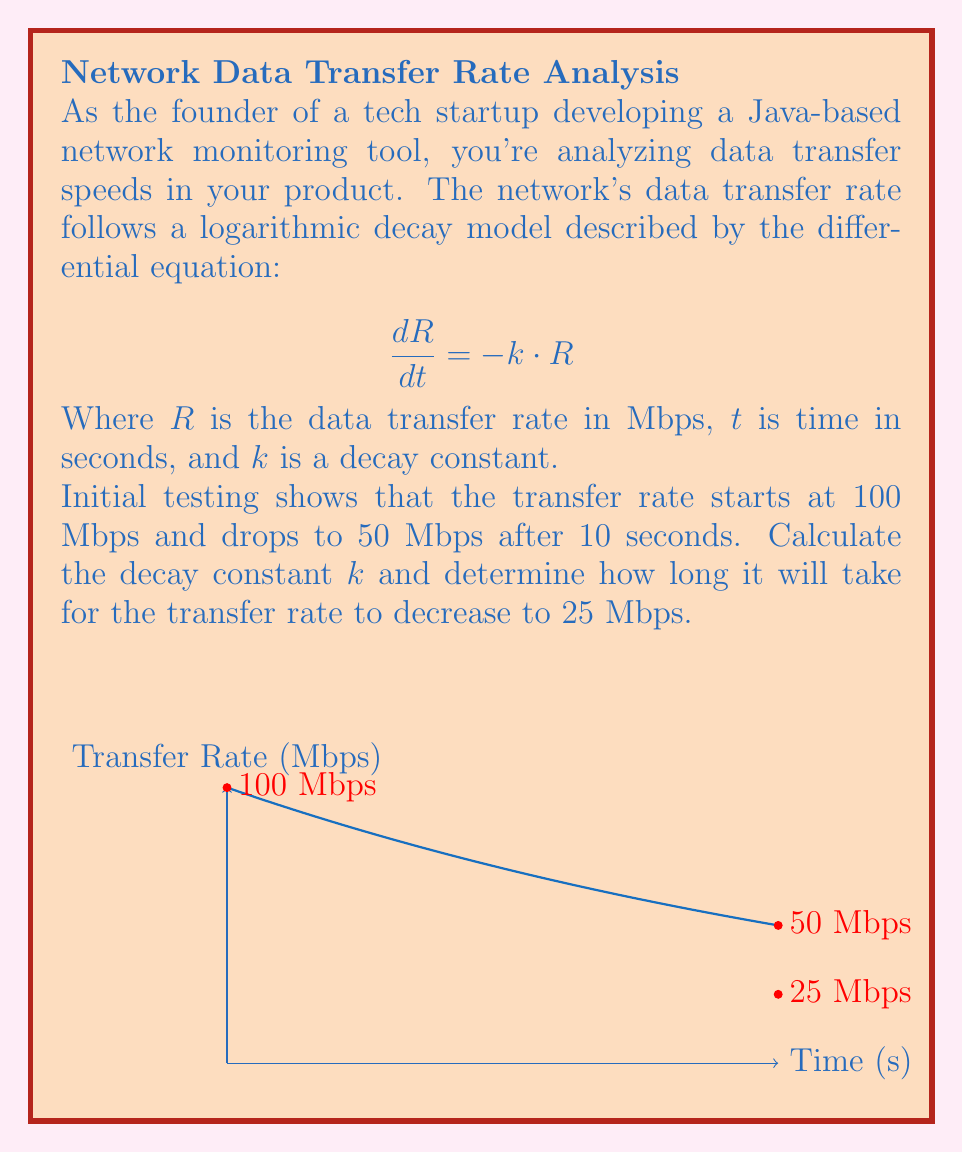Can you solve this math problem? Let's solve this problem step by step:

1) The general solution to the differential equation $\frac{dR}{dt} = -k \cdot R$ is:
   $$R(t) = R_0 \cdot e^{-kt}$$
   where $R_0$ is the initial transfer rate.

2) We know that $R_0 = 100$ Mbps and after 10 seconds, $R(10) = 50$ Mbps. Let's use these to find $k$:
   $$50 = 100 \cdot e^{-10k}$$

3) Dividing both sides by 100:
   $$0.5 = e^{-10k}$$

4) Taking the natural logarithm of both sides:
   $$\ln(0.5) = -10k$$

5) Solving for $k$:
   $$k = -\frac{\ln(0.5)}{10} \approx 0.069315$$

6) Now that we have $k$, let's find the time $t$ when the rate drops to 25 Mbps:
   $$25 = 100 \cdot e^{-0.069315t}$$

7) Dividing both sides by 100:
   $$0.25 = e^{-0.069315t}$$

8) Taking the natural logarithm of both sides:
   $$\ln(0.25) = -0.069315t$$

9) Solving for $t$:
   $$t = -\frac{\ln(0.25)}{0.069315} \approx 20.09$$

Therefore, it will take approximately 20.09 seconds for the transfer rate to decrease to 25 Mbps.
Answer: $k \approx 0.069315$, $t \approx 20.09$ seconds 